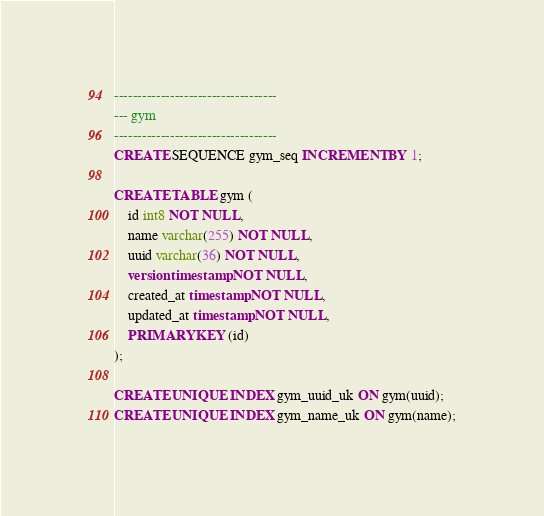<code> <loc_0><loc_0><loc_500><loc_500><_SQL_>-----------------------------------
--- gym
-----------------------------------
CREATE SEQUENCE gym_seq INCREMENT BY 1;

CREATE TABLE gym (
    id int8 NOT NULL,
    name varchar(255) NOT NULL,
    uuid varchar(36) NOT NULL,
    version timestamp NOT NULL,
    created_at timestamp NOT NULL,
    updated_at timestamp NOT NULL,
    PRIMARY KEY (id)
);

CREATE UNIQUE INDEX gym_uuid_uk ON gym(uuid);
CREATE UNIQUE INDEX gym_name_uk ON gym(name);
</code> 